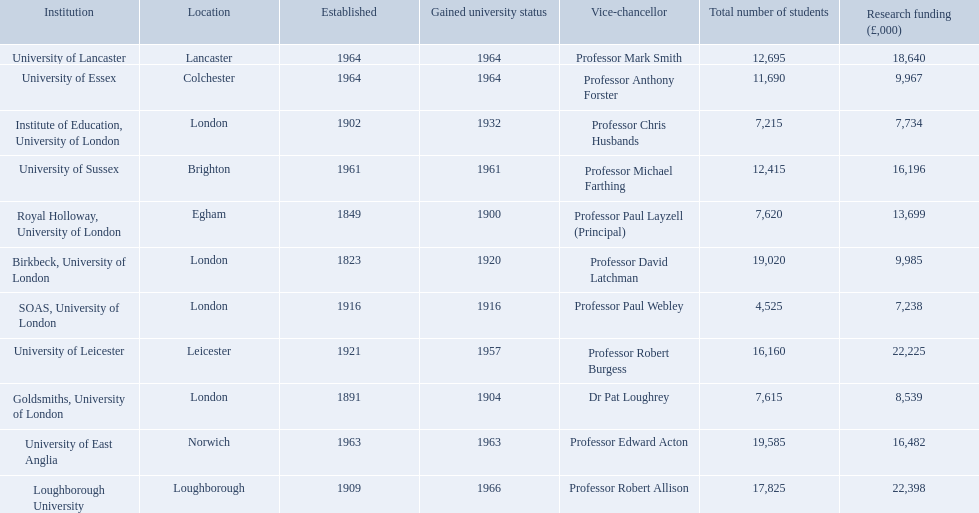Where is birbeck,university of london located? London. Which university was established in 1921? University of Leicester. Which institution gained university status recently? Loughborough University. 